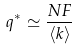Convert formula to latex. <formula><loc_0><loc_0><loc_500><loc_500>q ^ { * } \simeq \frac { N F } { \langle k \rangle }</formula> 